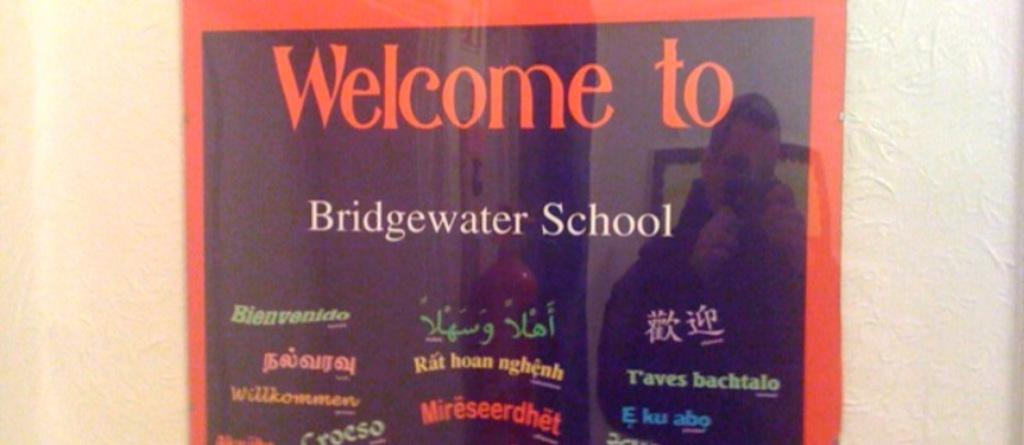<image>
Create a compact narrative representing the image presented. A black and red sign welcomes you to Bridgewater School. 